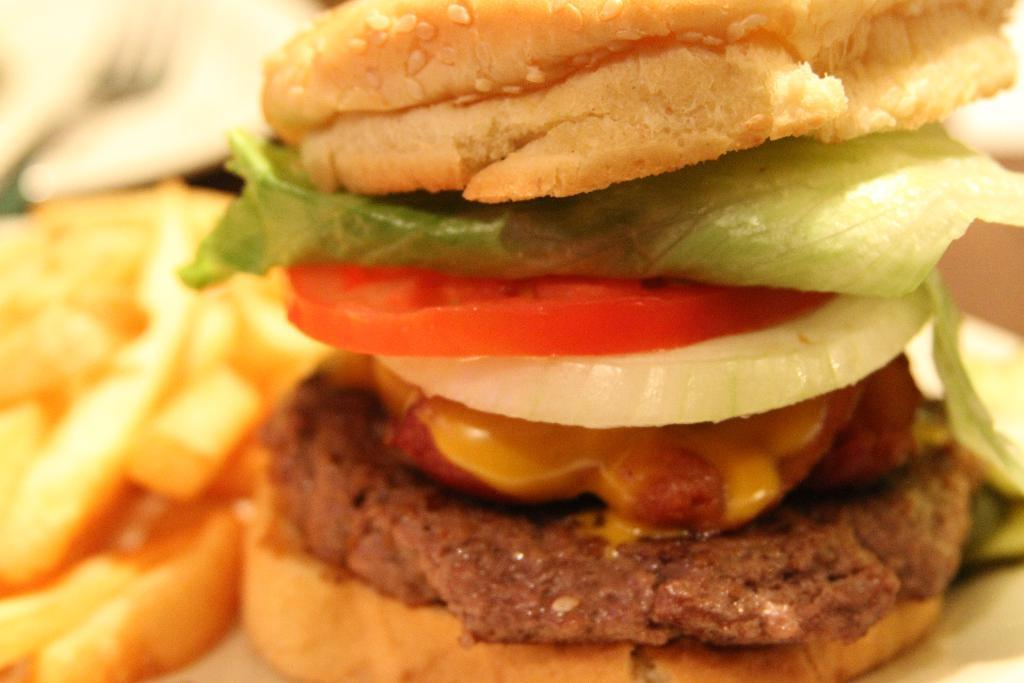What types of objects are present in the image? There are food items in the image. Can you describe the background of the image? The background of the image is blurred. What type of machine can be seen operating in the image? There is no machine present in the image; it only features food items and a blurred background. How many chains are visible in the image? There are no chains present in the image. 